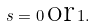<formula> <loc_0><loc_0><loc_500><loc_500>s = 0 \, \text {or} \, 1 .</formula> 